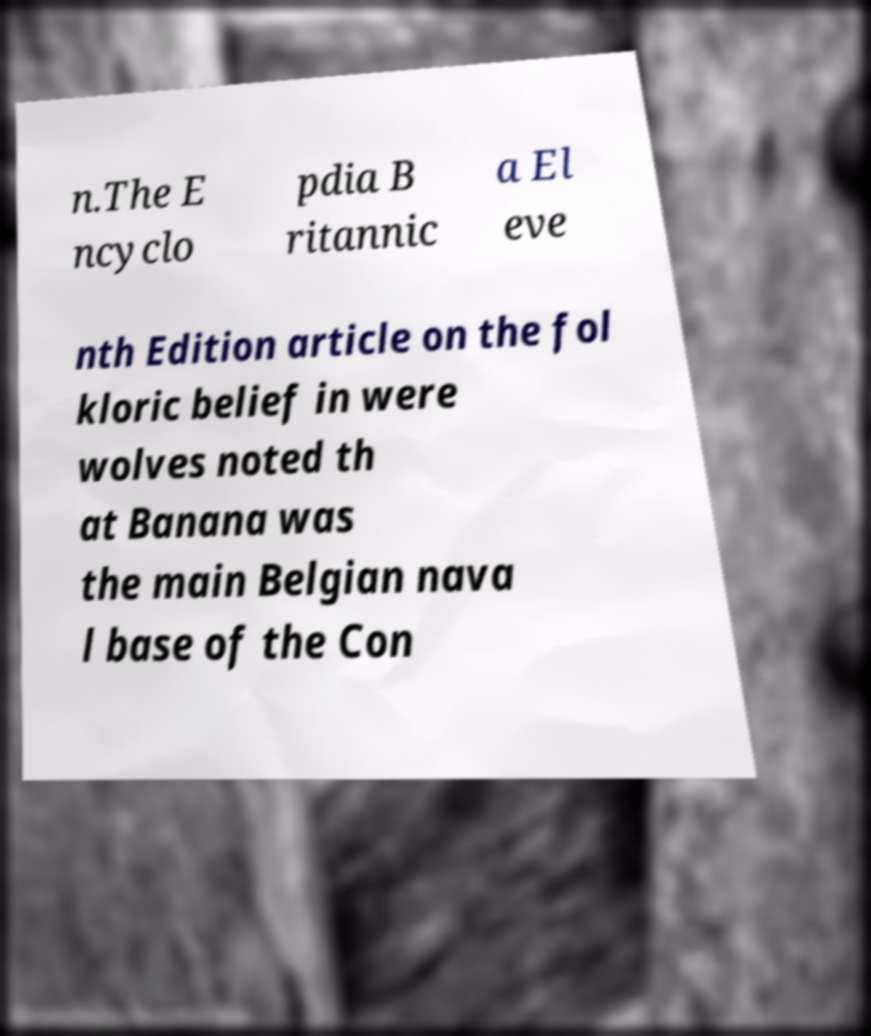Could you extract and type out the text from this image? n.The E ncyclo pdia B ritannic a El eve nth Edition article on the fol kloric belief in were wolves noted th at Banana was the main Belgian nava l base of the Con 